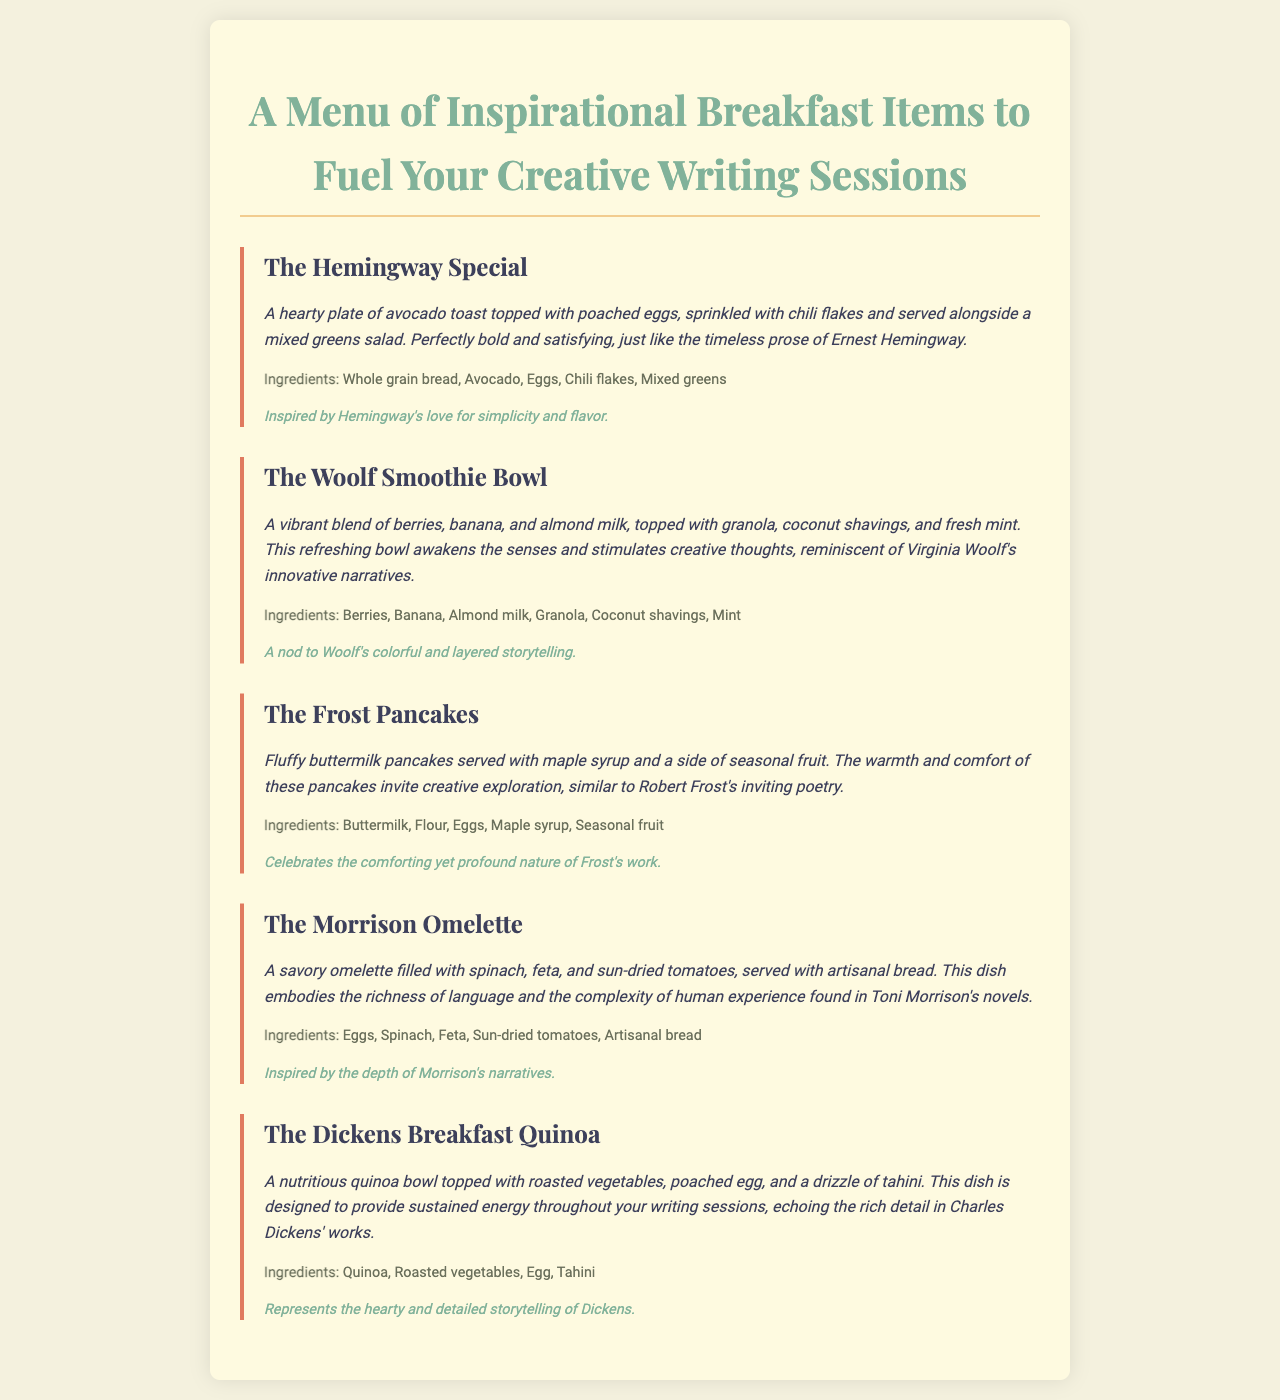what is the name of the first menu item? The first menu item is the title of the dish "The Hemingway Special."
Answer: The Hemingway Special how many ingredients are listed for The Morrison Omelette? The ingredients for The Morrison Omelette are Eggs, Spinach, Feta, Sun-dried tomatoes, Artisanal bread, totaling five ingredients.
Answer: 5 what dessert is associated with The Dickens Breakfast Quinoa? There is no dessert mentioned for The Dickens Breakfast Quinoa in the menu document.
Answer: None which menu item features berries? The menu item that features berries is "The Woolf Smoothie Bowl."
Answer: The Woolf Smoothie Bowl what is the main protein in The Frost Pancakes? The main protein in The Frost Pancakes is Eggs, mentioned along with the buttermilk in the pancake recipe.
Answer: Eggs which menu item is inspired by Toni Morrison? The menu item inspired by Toni Morrison is "The Morrison Omelette."
Answer: The Morrison Omelette what type of bread accompanies The Hemingway Special? The Hemingway Special is served alongside whole grain bread.
Answer: Whole grain bread which item is described as a blend of berries and banana? The item described as a blend of berries and banana is "The Woolf Smoothie Bowl."
Answer: The Woolf Smoothie Bowl 